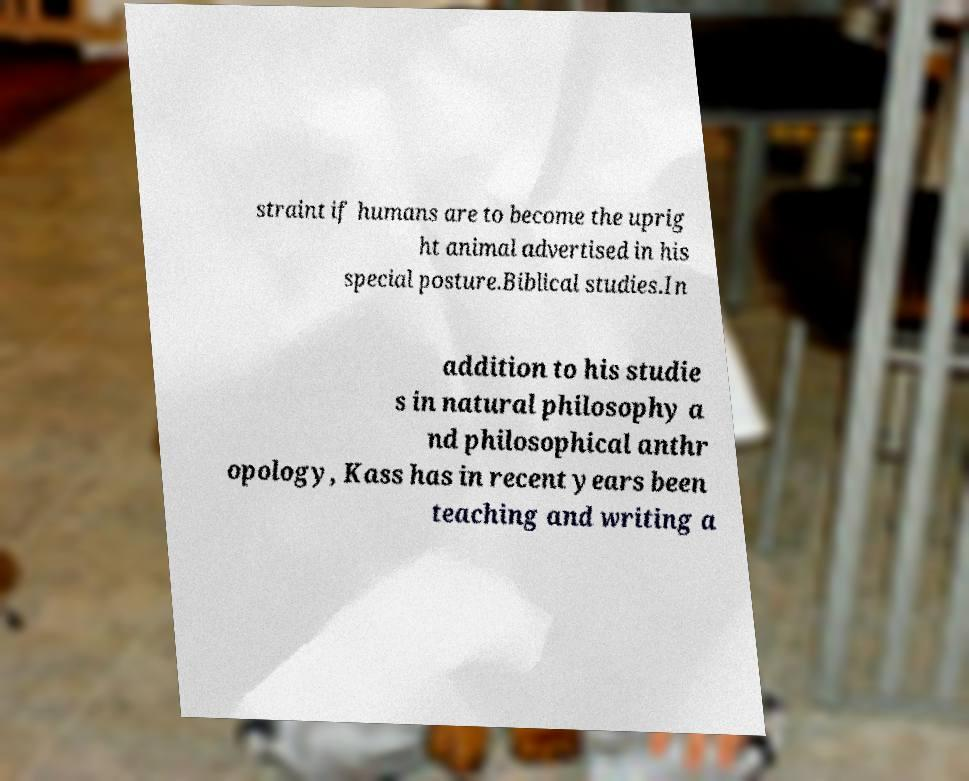Could you extract and type out the text from this image? straint if humans are to become the uprig ht animal advertised in his special posture.Biblical studies.In addition to his studie s in natural philosophy a nd philosophical anthr opology, Kass has in recent years been teaching and writing a 